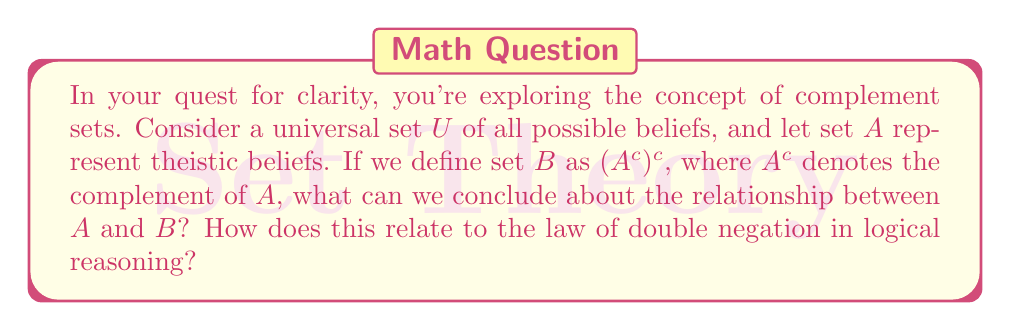Solve this math problem. Let's approach this step-by-step:

1) First, let's understand what each set represents:
   - $U$ is the universal set of all possible beliefs
   - $A$ is the set of theistic beliefs
   - $A^c$ is the complement of $A$, which would represent non-theistic beliefs

2) Now, we're asked about set $B$, which is defined as $(A^c)^c$. This is the complement of the complement of $A$.

3) In set theory, there's a fundamental property known as the double complement law:
   $$(X^c)^c = X$$
   This states that the complement of the complement of a set is the original set itself.

4) Applying this to our problem:
   $B = (A^c)^c = A$

5) This means that set $B$ is actually identical to set $A$.

6) In terms of logical reasoning, this corresponds to the law of double negation:
   $$\neg(\neg p) \equiv p$$
   Where $\neg$ represents negation, and $p$ is a proposition.

7) Just as double negation in logic returns you to the original proposition, taking the complement of a complement in set theory returns you to the original set.

8) In the context of beliefs, this means that if you negate non-theistic beliefs (the complement of theistic beliefs), you end up back at theistic beliefs.

This demonstrates how set theory operations can mirror logical operations, providing a mathematical framework for reasoning about categories and their relationships.
Answer: $B = A$. The set $B$, defined as $(A^c)^c$, is identical to set $A$ due to the double complement law in set theory, which corresponds to the law of double negation in logical reasoning. 